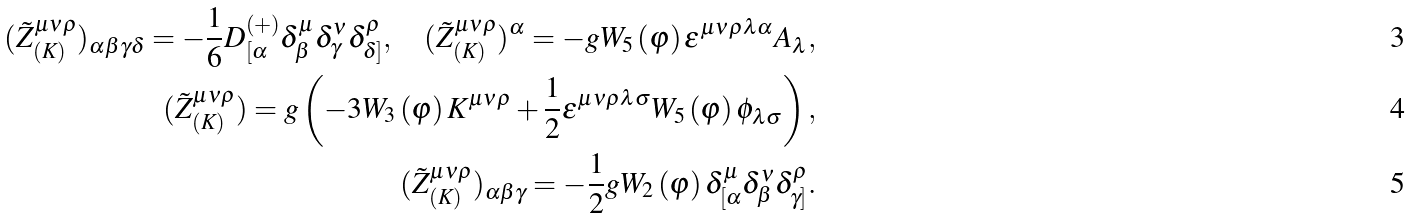<formula> <loc_0><loc_0><loc_500><loc_500>( \tilde { Z } _ { ( K ) } ^ { \mu \nu \rho } ) _ { \alpha \beta \gamma \delta } = - \frac { 1 } { 6 } D _ { [ \alpha } ^ { \left ( + \right ) } \delta _ { \beta } ^ { \mu } \delta _ { \gamma } ^ { \nu } \delta _ { \delta ] } ^ { \rho } , \quad ( \tilde { Z } _ { ( K ) } ^ { \mu \nu \rho } ) ^ { \alpha } = - g W _ { 5 } \left ( \varphi \right ) \varepsilon ^ { \mu \nu \rho \lambda \alpha } A _ { \lambda } , \\ ( \tilde { Z } _ { ( K ) } ^ { \mu \nu \rho } ) = g \left ( - 3 W _ { 3 } \left ( \varphi \right ) K ^ { \mu \nu \rho } + \frac { 1 } { 2 } \varepsilon ^ { \mu \nu \rho \lambda \sigma } W _ { 5 } \left ( \varphi \right ) \phi _ { \lambda \sigma } \right ) , \\ ( \tilde { Z } _ { ( K ) } ^ { \mu \nu \rho } ) _ { \alpha \beta \gamma } = - \frac { 1 } { 2 } g W _ { 2 } \left ( \varphi \right ) \delta _ { [ \alpha } ^ { \mu } \delta _ { \beta } ^ { \nu } \delta _ { \gamma ] } ^ { \rho } .</formula> 